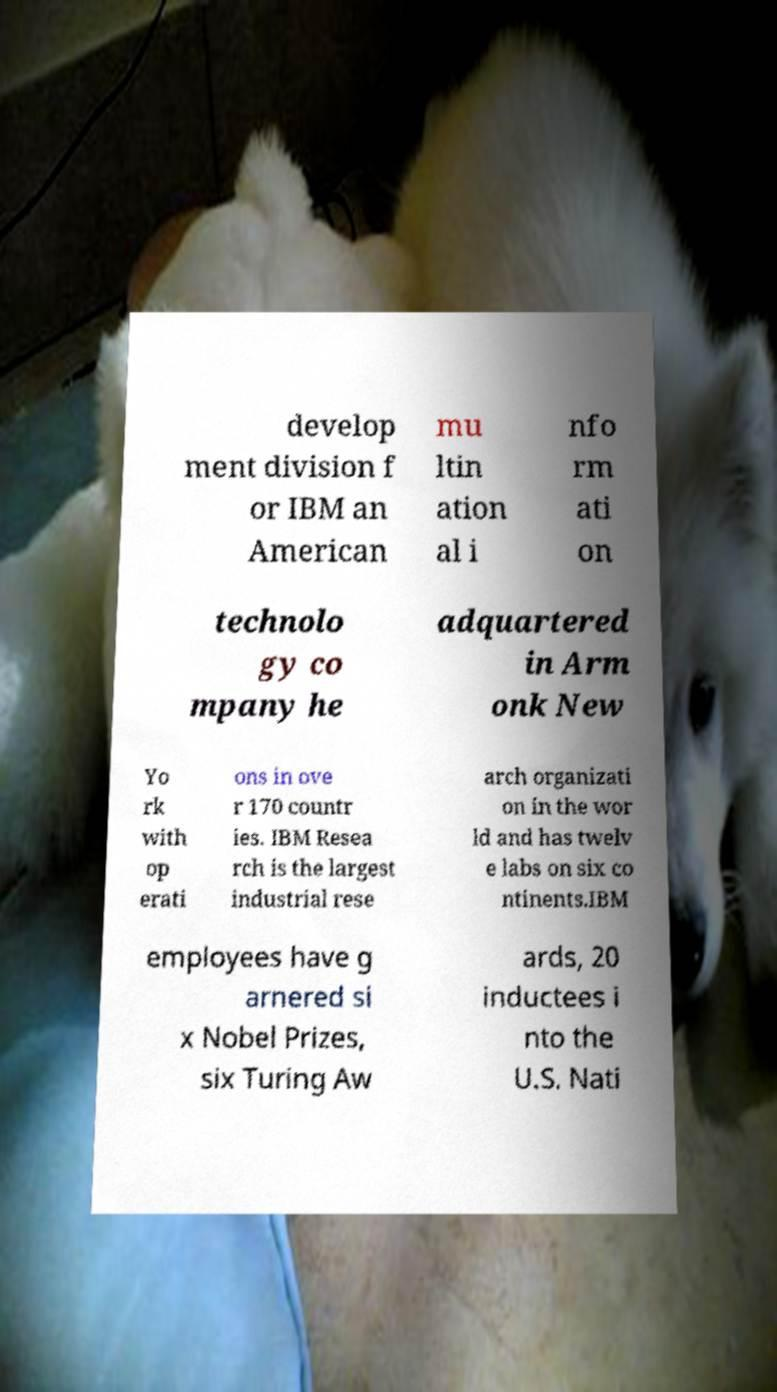Could you extract and type out the text from this image? develop ment division f or IBM an American mu ltin ation al i nfo rm ati on technolo gy co mpany he adquartered in Arm onk New Yo rk with op erati ons in ove r 170 countr ies. IBM Resea rch is the largest industrial rese arch organizati on in the wor ld and has twelv e labs on six co ntinents.IBM employees have g arnered si x Nobel Prizes, six Turing Aw ards, 20 inductees i nto the U.S. Nati 